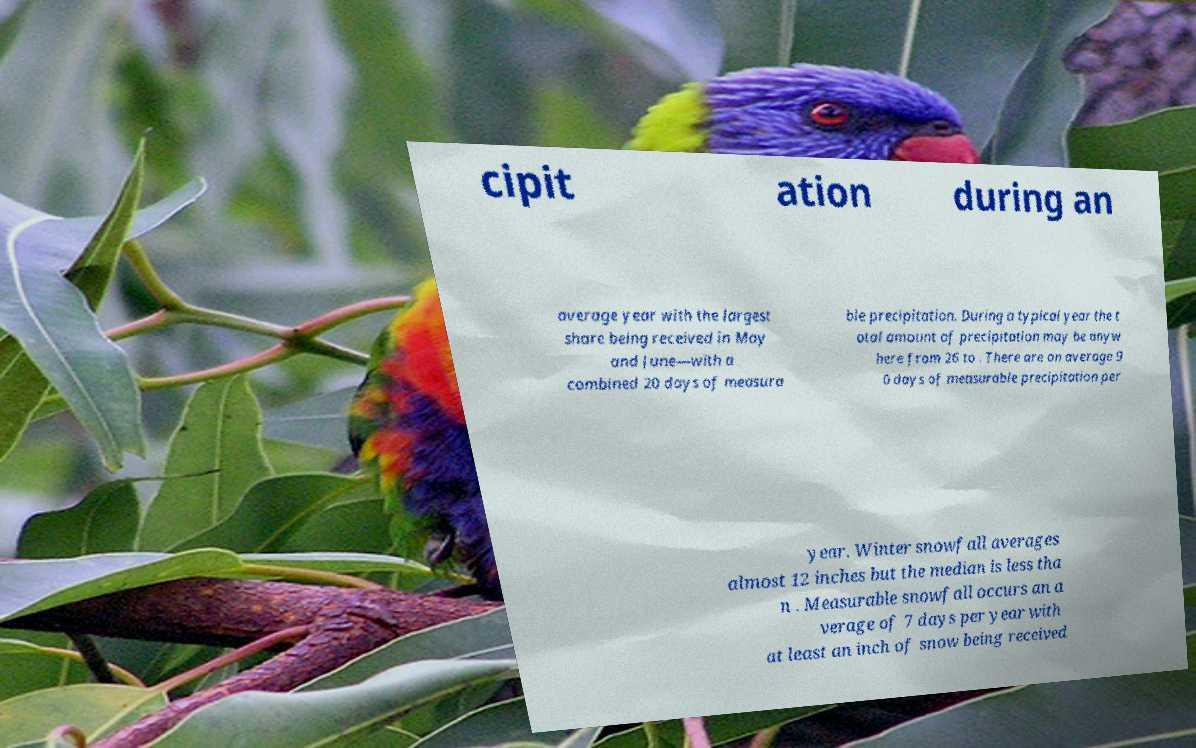I need the written content from this picture converted into text. Can you do that? cipit ation during an average year with the largest share being received in May and June—with a combined 20 days of measura ble precipitation. During a typical year the t otal amount of precipitation may be anyw here from 26 to . There are on average 9 0 days of measurable precipitation per year. Winter snowfall averages almost 12 inches but the median is less tha n . Measurable snowfall occurs an a verage of 7 days per year with at least an inch of snow being received 